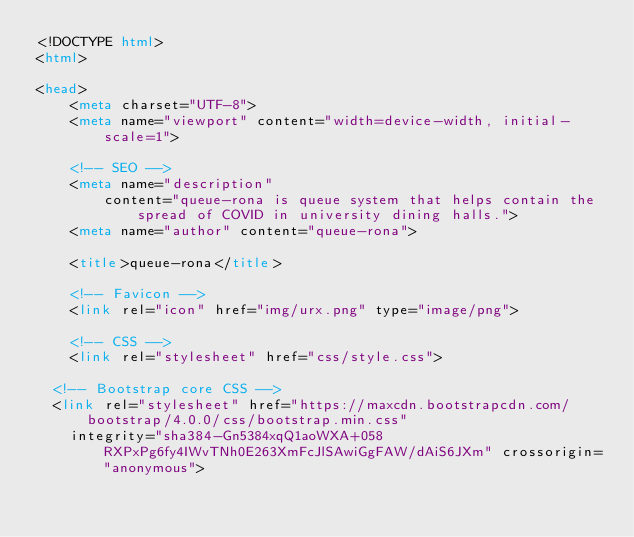<code> <loc_0><loc_0><loc_500><loc_500><_HTML_><!DOCTYPE html>
<html>

<head>
    <meta charset="UTF-8">
    <meta name="viewport" content="width=device-width, initial-scale=1">

    <!-- SEO -->
    <meta name="description"
        content="queue-rona is queue system that helps contain the spread of COVID in university dining halls.">
    <meta name="author" content="queue-rona">

    <title>queue-rona</title>

    <!-- Favicon -->
    <link rel="icon" href="img/urx.png" type="image/png">

    <!-- CSS -->
    <link rel="stylesheet" href="css/style.css">

  <!-- Bootstrap core CSS -->
  <link rel="stylesheet" href="https://maxcdn.bootstrapcdn.com/bootstrap/4.0.0/css/bootstrap.min.css"
    integrity="sha384-Gn5384xqQ1aoWXA+058RXPxPg6fy4IWvTNh0E263XmFcJlSAwiGgFAW/dAiS6JXm" crossorigin="anonymous"></code> 